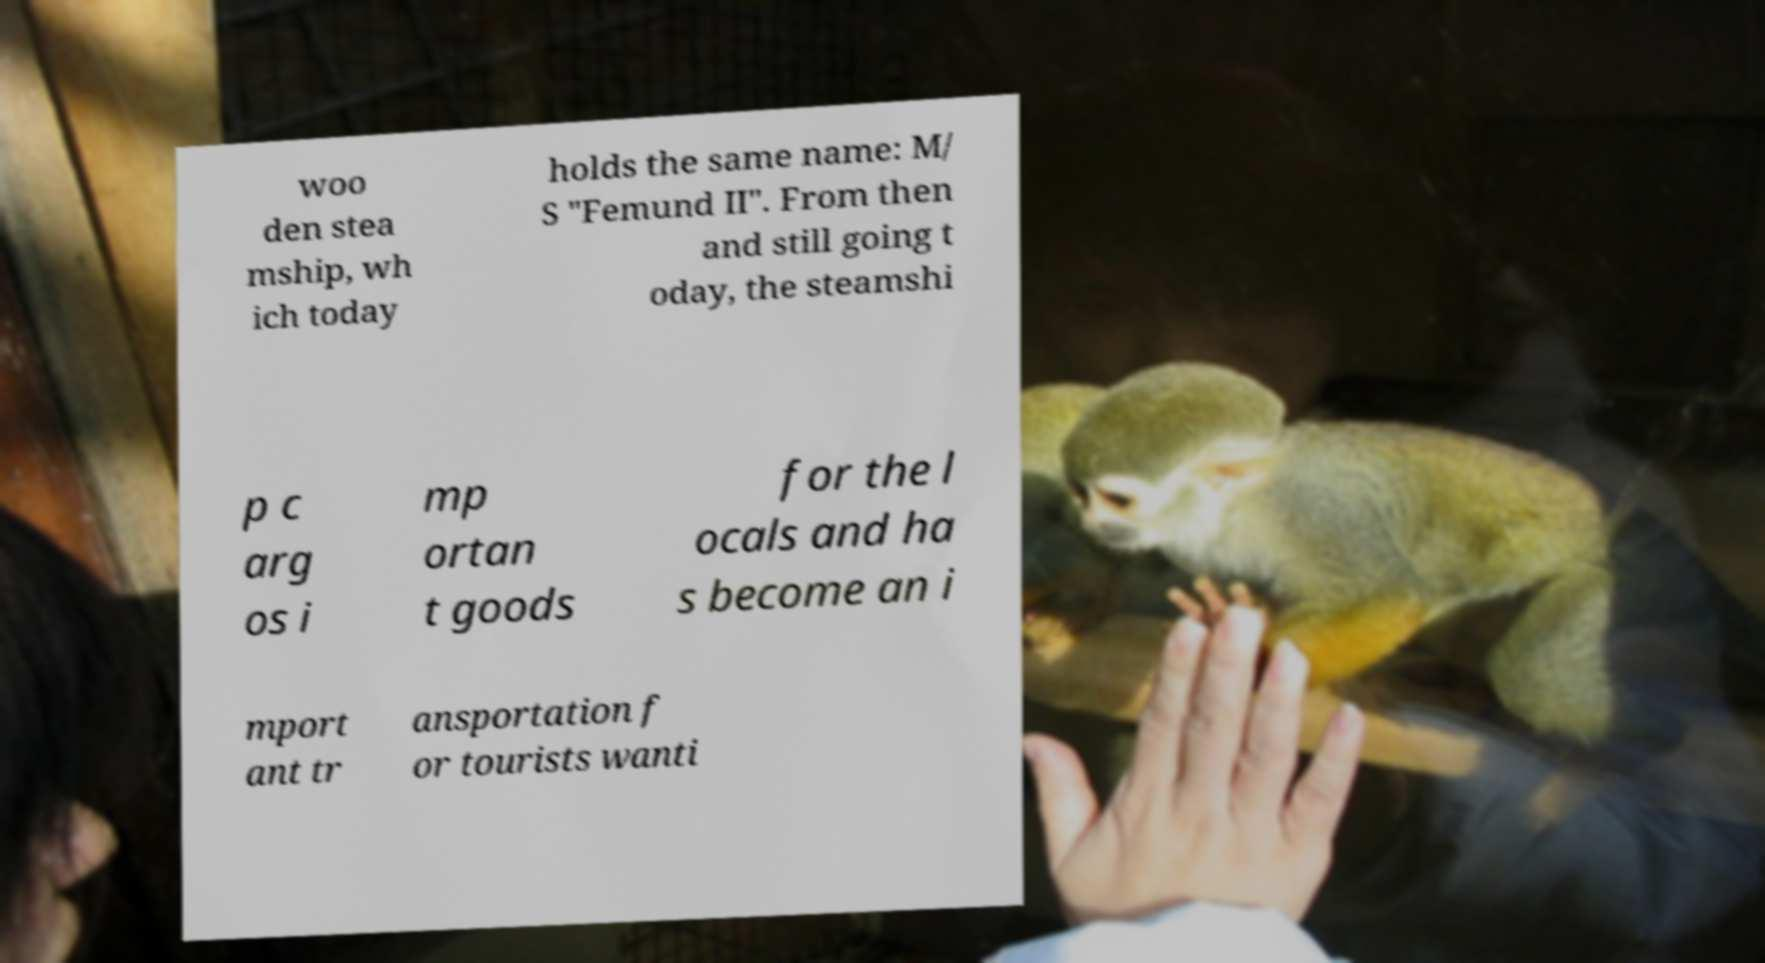I need the written content from this picture converted into text. Can you do that? woo den stea mship, wh ich today holds the same name: M/ S "Femund II". From then and still going t oday, the steamshi p c arg os i mp ortan t goods for the l ocals and ha s become an i mport ant tr ansportation f or tourists wanti 